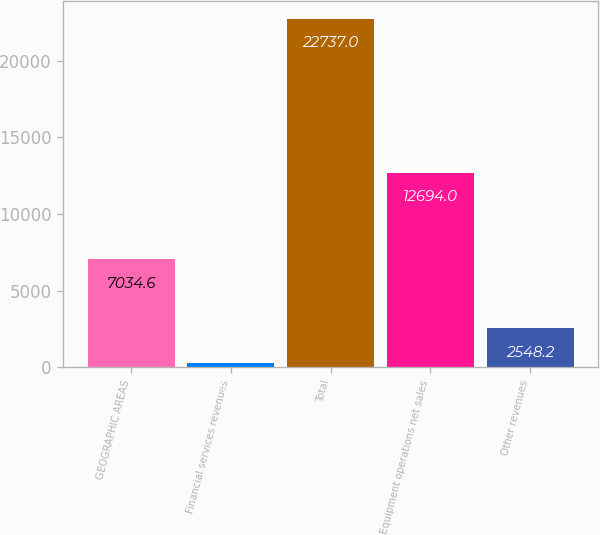Convert chart. <chart><loc_0><loc_0><loc_500><loc_500><bar_chart><fcel>GEOGRAPHIC AREAS<fcel>Financial services revenues<fcel>Total<fcel>Equipment operations net sales<fcel>Other revenues<nl><fcel>7034.6<fcel>305<fcel>22737<fcel>12694<fcel>2548.2<nl></chart> 